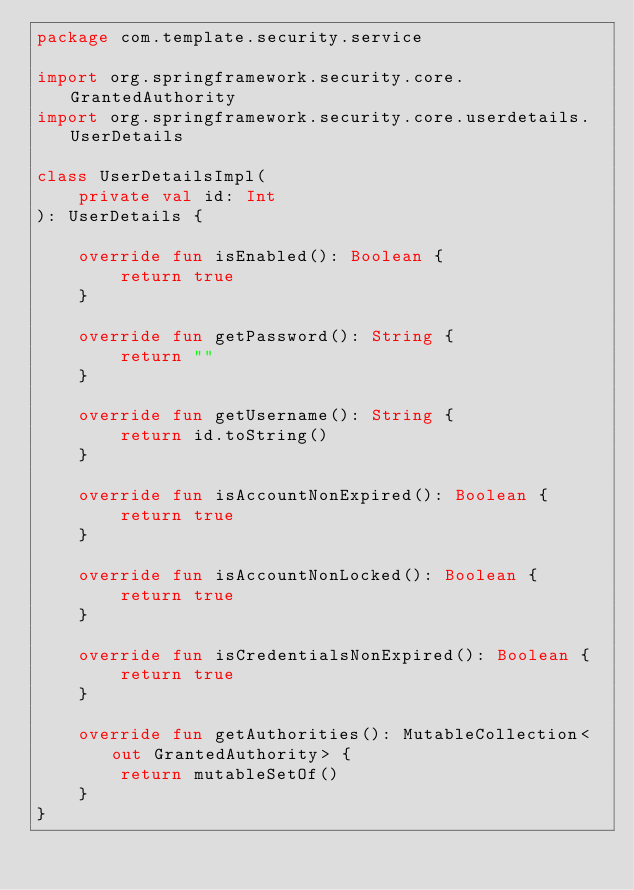Convert code to text. <code><loc_0><loc_0><loc_500><loc_500><_Kotlin_>package com.template.security.service

import org.springframework.security.core.GrantedAuthority
import org.springframework.security.core.userdetails.UserDetails

class UserDetailsImpl(
    private val id: Int
): UserDetails {

    override fun isEnabled(): Boolean {
        return true
    }

    override fun getPassword(): String {
        return ""
    }

    override fun getUsername(): String {
        return id.toString()
    }

    override fun isAccountNonExpired(): Boolean {
        return true
    }

    override fun isAccountNonLocked(): Boolean {
        return true
    }

    override fun isCredentialsNonExpired(): Boolean {
        return true
    }

    override fun getAuthorities(): MutableCollection<out GrantedAuthority> {
        return mutableSetOf()
    }
}</code> 